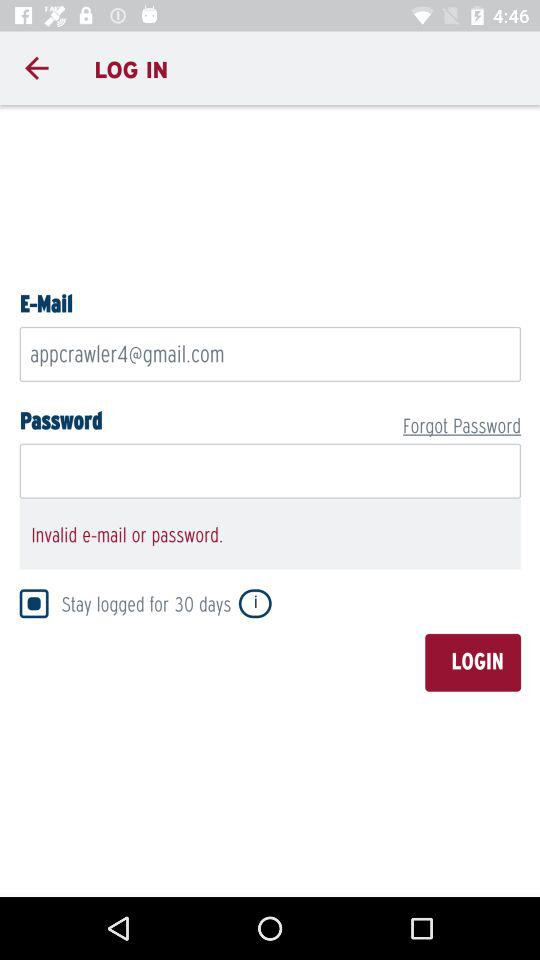How long can a user stay logged in? A user can stay logged in for 30 days. 